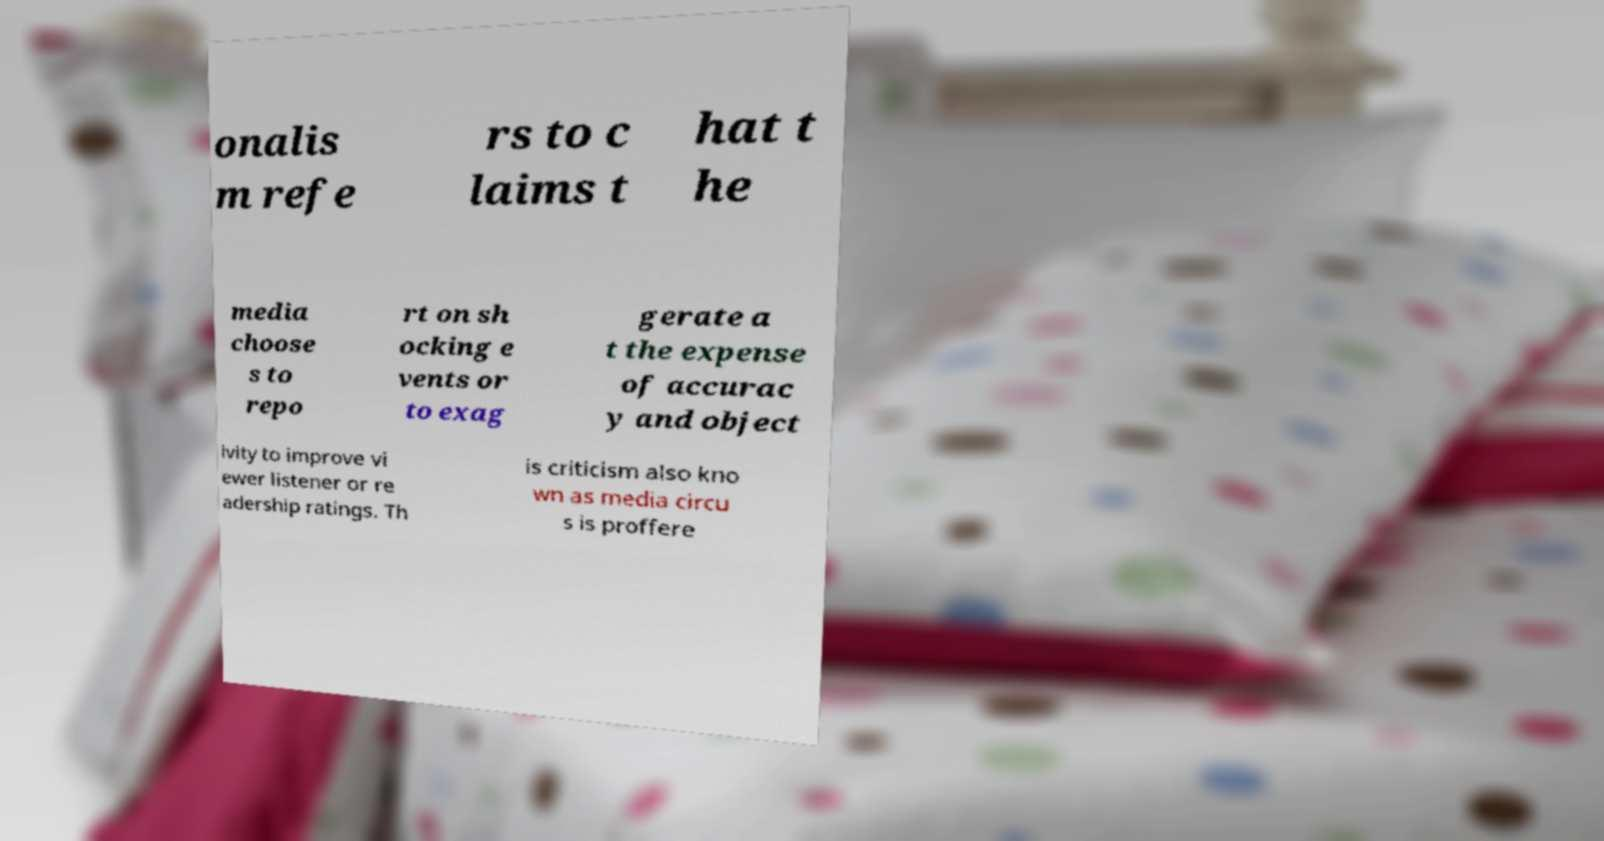Could you extract and type out the text from this image? onalis m refe rs to c laims t hat t he media choose s to repo rt on sh ocking e vents or to exag gerate a t the expense of accurac y and object ivity to improve vi ewer listener or re adership ratings. Th is criticism also kno wn as media circu s is proffere 